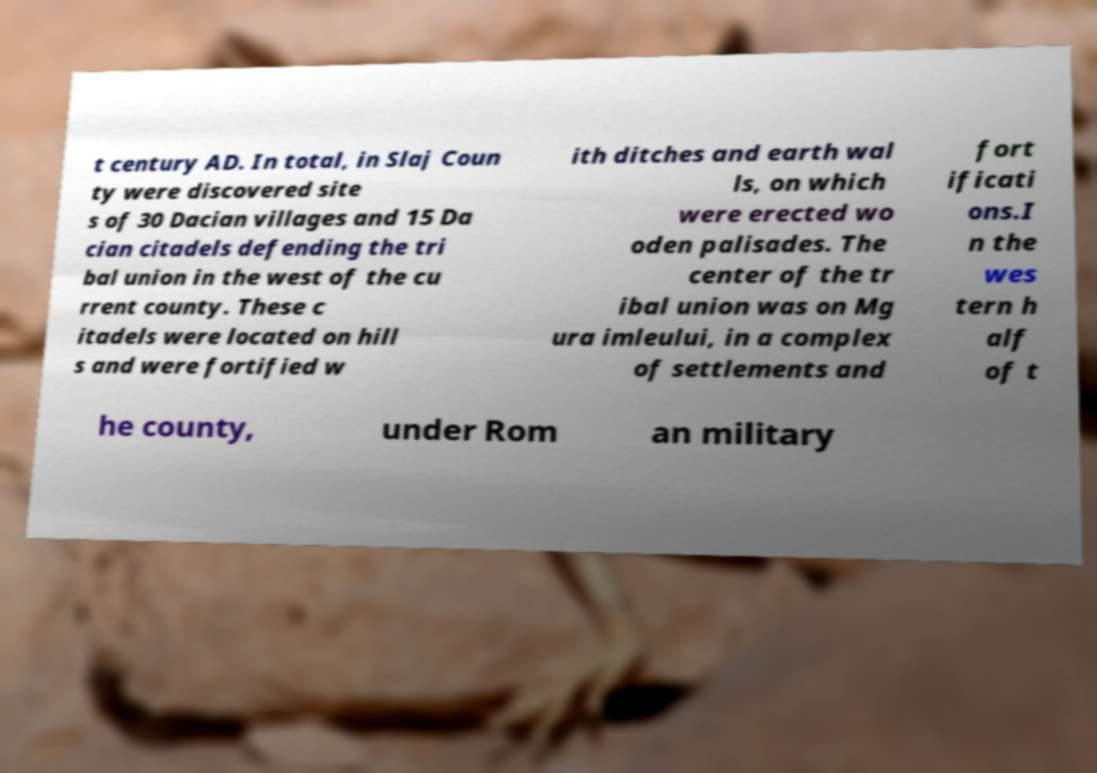Can you accurately transcribe the text from the provided image for me? t century AD. In total, in Slaj Coun ty were discovered site s of 30 Dacian villages and 15 Da cian citadels defending the tri bal union in the west of the cu rrent county. These c itadels were located on hill s and were fortified w ith ditches and earth wal ls, on which were erected wo oden palisades. The center of the tr ibal union was on Mg ura imleului, in a complex of settlements and fort ificati ons.I n the wes tern h alf of t he county, under Rom an military 